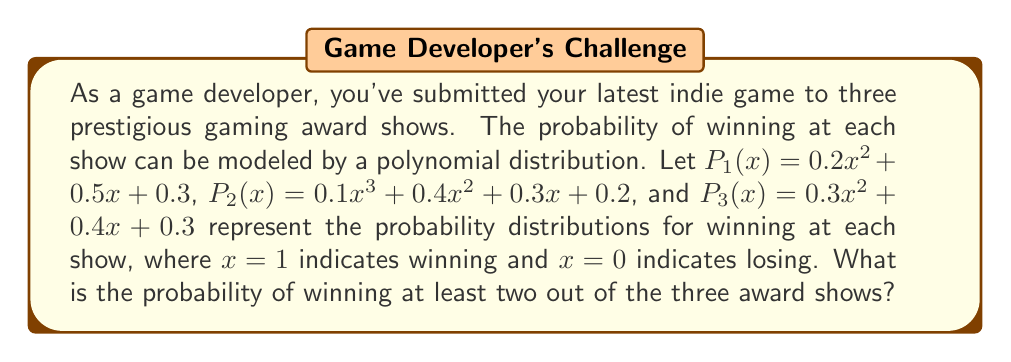Can you answer this question? To solve this problem, we need to calculate the probability of winning at least two out of three award shows. We can do this by finding the probability of winning all three, plus the probability of winning exactly two out of three.

Step 1: Calculate the probability of winning each individual show.
For each polynomial, we substitute $x = 1$ to find the probability of winning:

$P_1(1) = 0.2(1)^2 + 0.5(1) + 0.3 = 1$
$P_2(1) = 0.1(1)^3 + 0.4(1)^2 + 0.3(1) + 0.2 = 1$
$P_3(1) = 0.3(1)^2 + 0.4(1) + 0.3 = 1$

Step 2: Calculate the probability of winning all three shows.
$P(\text{all three}) = P_1(1) \times P_2(1) \times P_3(1) = 1 \times 1 \times 1 = 1$

Step 3: Calculate the probability of winning exactly two out of three shows.
We need to consider three cases: winning shows 1 and 2, winning shows 1 and 3, and winning shows 2 and 3.

$P(\text{1 and 2}) = P_1(1) \times P_2(1) \times (1 - P_3(1)) = 1 \times 1 \times 0 = 0$
$P(\text{1 and 3}) = P_1(1) \times (1 - P_2(1)) \times P_3(1) = 1 \times 0 \times 1 = 0$
$P(\text{2 and 3}) = (1 - P_1(1)) \times P_2(1) \times P_3(1) = 0 \times 1 \times 1 = 0$

Step 4: Sum the probabilities of winning all three and winning exactly two out of three.
$P(\text{at least two}) = P(\text{all three}) + P(\text{1 and 2}) + P(\text{1 and 3}) + P(\text{2 and 3})$
$P(\text{at least two}) = 1 + 0 + 0 + 0 = 1$

Therefore, the probability of winning at least two out of the three award shows is 1, or 100%.
Answer: The probability of winning at least two out of the three award shows is 1 (or 100%). 